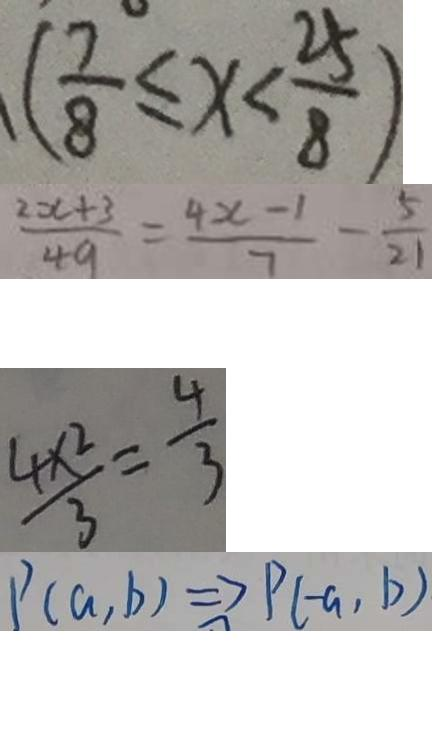Convert formula to latex. <formula><loc_0><loc_0><loc_500><loc_500>( \frac { 7 } { 8 } \leq x < \frac { 2 5 } { 8 } ) 
 \frac { 2 x + 3 } { 4 9 } = \frac { 4 x - 1 } { 7 } - \frac { 5 } { 2 1 } 
 \frac { 4 \times 2 } { 3 } = \frac { 4 } { 3 } 
 P ( a , b ) \Rightarrow P ( - a , b )</formula> 